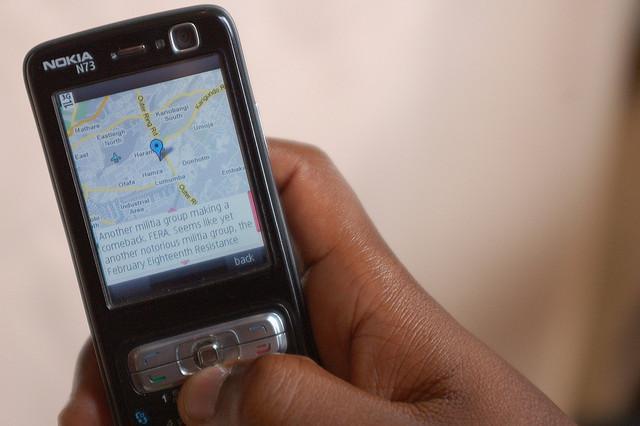How many toilets have the lid open?
Give a very brief answer. 0. 